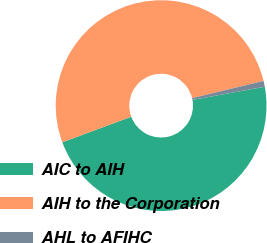Convert chart. <chart><loc_0><loc_0><loc_500><loc_500><pie_chart><fcel>AIC to AIH<fcel>AIH to the Corporation<fcel>AHL to AFIHC<nl><fcel>47.21%<fcel>51.88%<fcel>0.9%<nl></chart> 